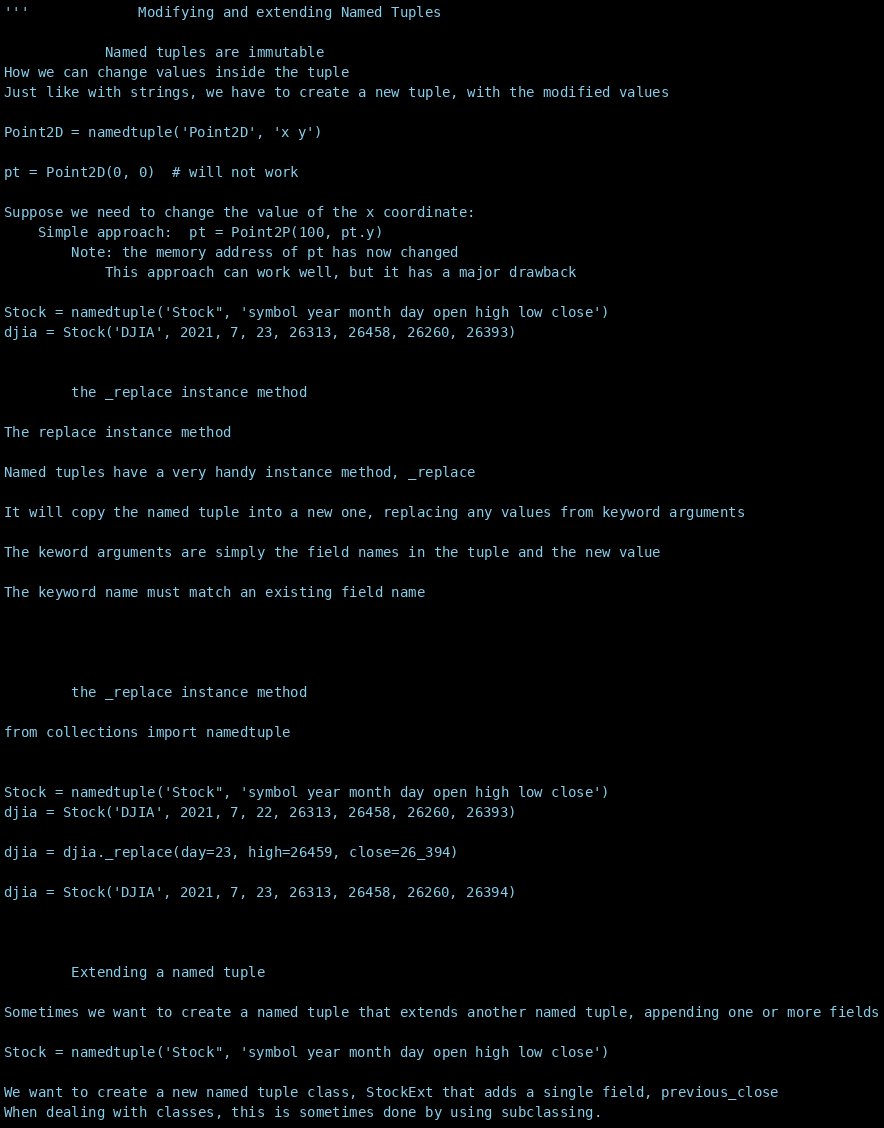Convert code to text. <code><loc_0><loc_0><loc_500><loc_500><_Python_>'''             Modifying and extending Named Tuples

            Named tuples are immutable
How we can change values inside the tuple
Just like with strings, we have to create a new tuple, with the modified values

Point2D = namedtuple('Point2D', 'x y')

pt = Point2D(0, 0)  # will not work

Suppose we need to change the value of the x coordinate:
    Simple approach:  pt = Point2P(100, pt.y)
        Note: the memory address of pt has now changed
            This approach can work well, but it has a major drawback

Stock = namedtuple('Stock", 'symbol year month day open high low close')
djia = Stock('DJIA', 2021, 7, 23, 26313, 26458, 26260, 26393)


        the _replace instance method

The replace instance method

Named tuples have a very handy instance method, _replace

It will copy the named tuple into a new one, replacing any values from keyword arguments

The keword arguments are simply the field names in the tuple and the new value

The keyword name must match an existing field name




        the _replace instance method

from collections import namedtuple


Stock = namedtuple('Stock", 'symbol year month day open high low close')
djia = Stock('DJIA', 2021, 7, 22, 26313, 26458, 26260, 26393)

djia = djia._replace(day=23, high=26459, close=26_394)

djia = Stock('DJIA', 2021, 7, 23, 26313, 26458, 26260, 26394)



        Extending a named tuple

Sometimes we want to create a named tuple that extends another named tuple, appending one or more fields

Stock = namedtuple('Stock", 'symbol year month day open high low close')

We want to create a new named tuple class, StockExt that adds a single field, previous_close
When dealing with classes, this is sometimes done by using subclassing.</code> 